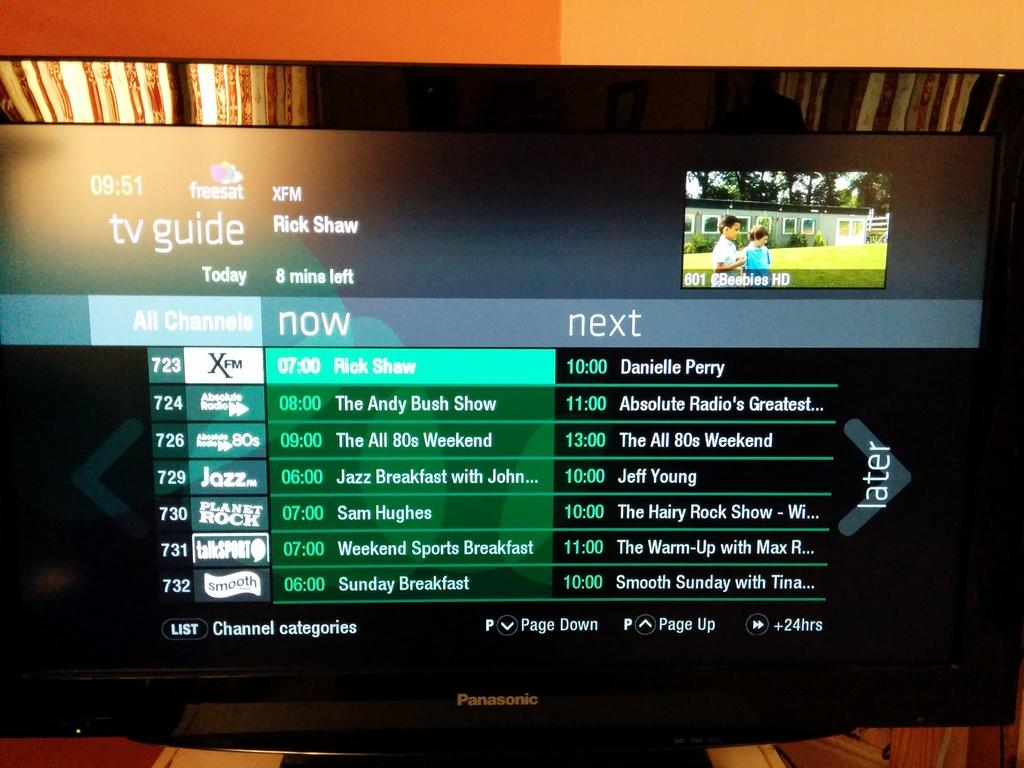What is the main object in the image? There is a screen in the image. What can be seen on the screen? Something is written on the screen, and there is an image in the top corner of the screen. What is depicted in the image on the screen? The image contains children, a grass lawn, a building, and trees. What type of pancake is being cooked in the image? There is no pancake or cooking activity present in the image. What religious symbol can be seen in the image? There is no religious symbol present in the image. 